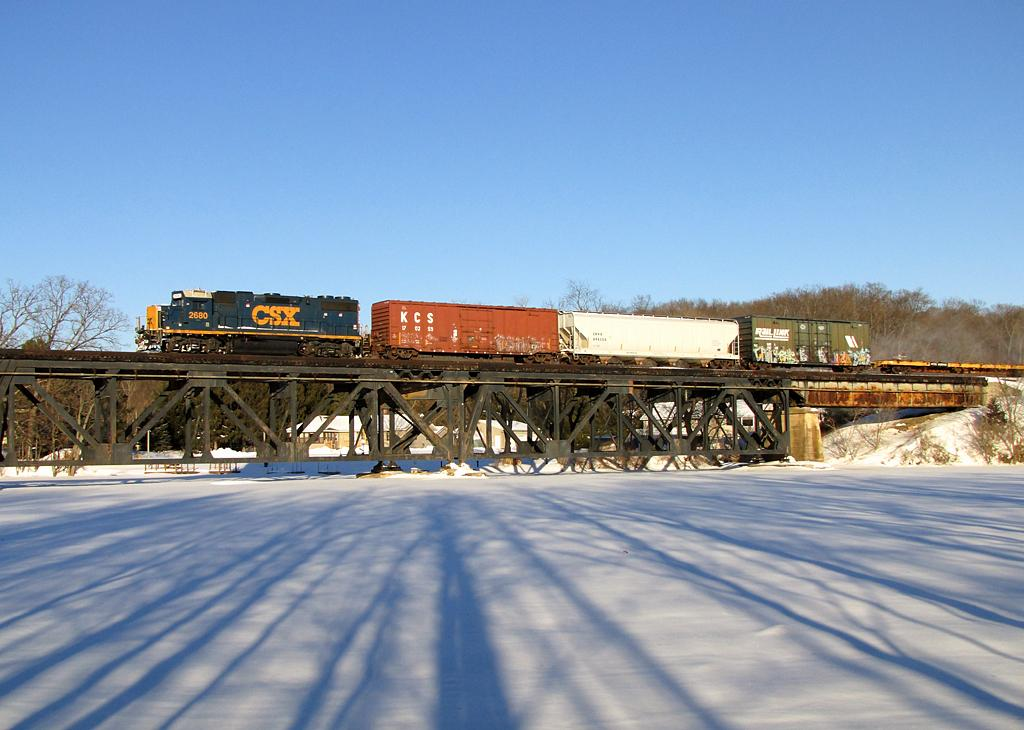<image>
Give a short and clear explanation of the subsequent image. A CSX train engine pulling other cars across a trestle 